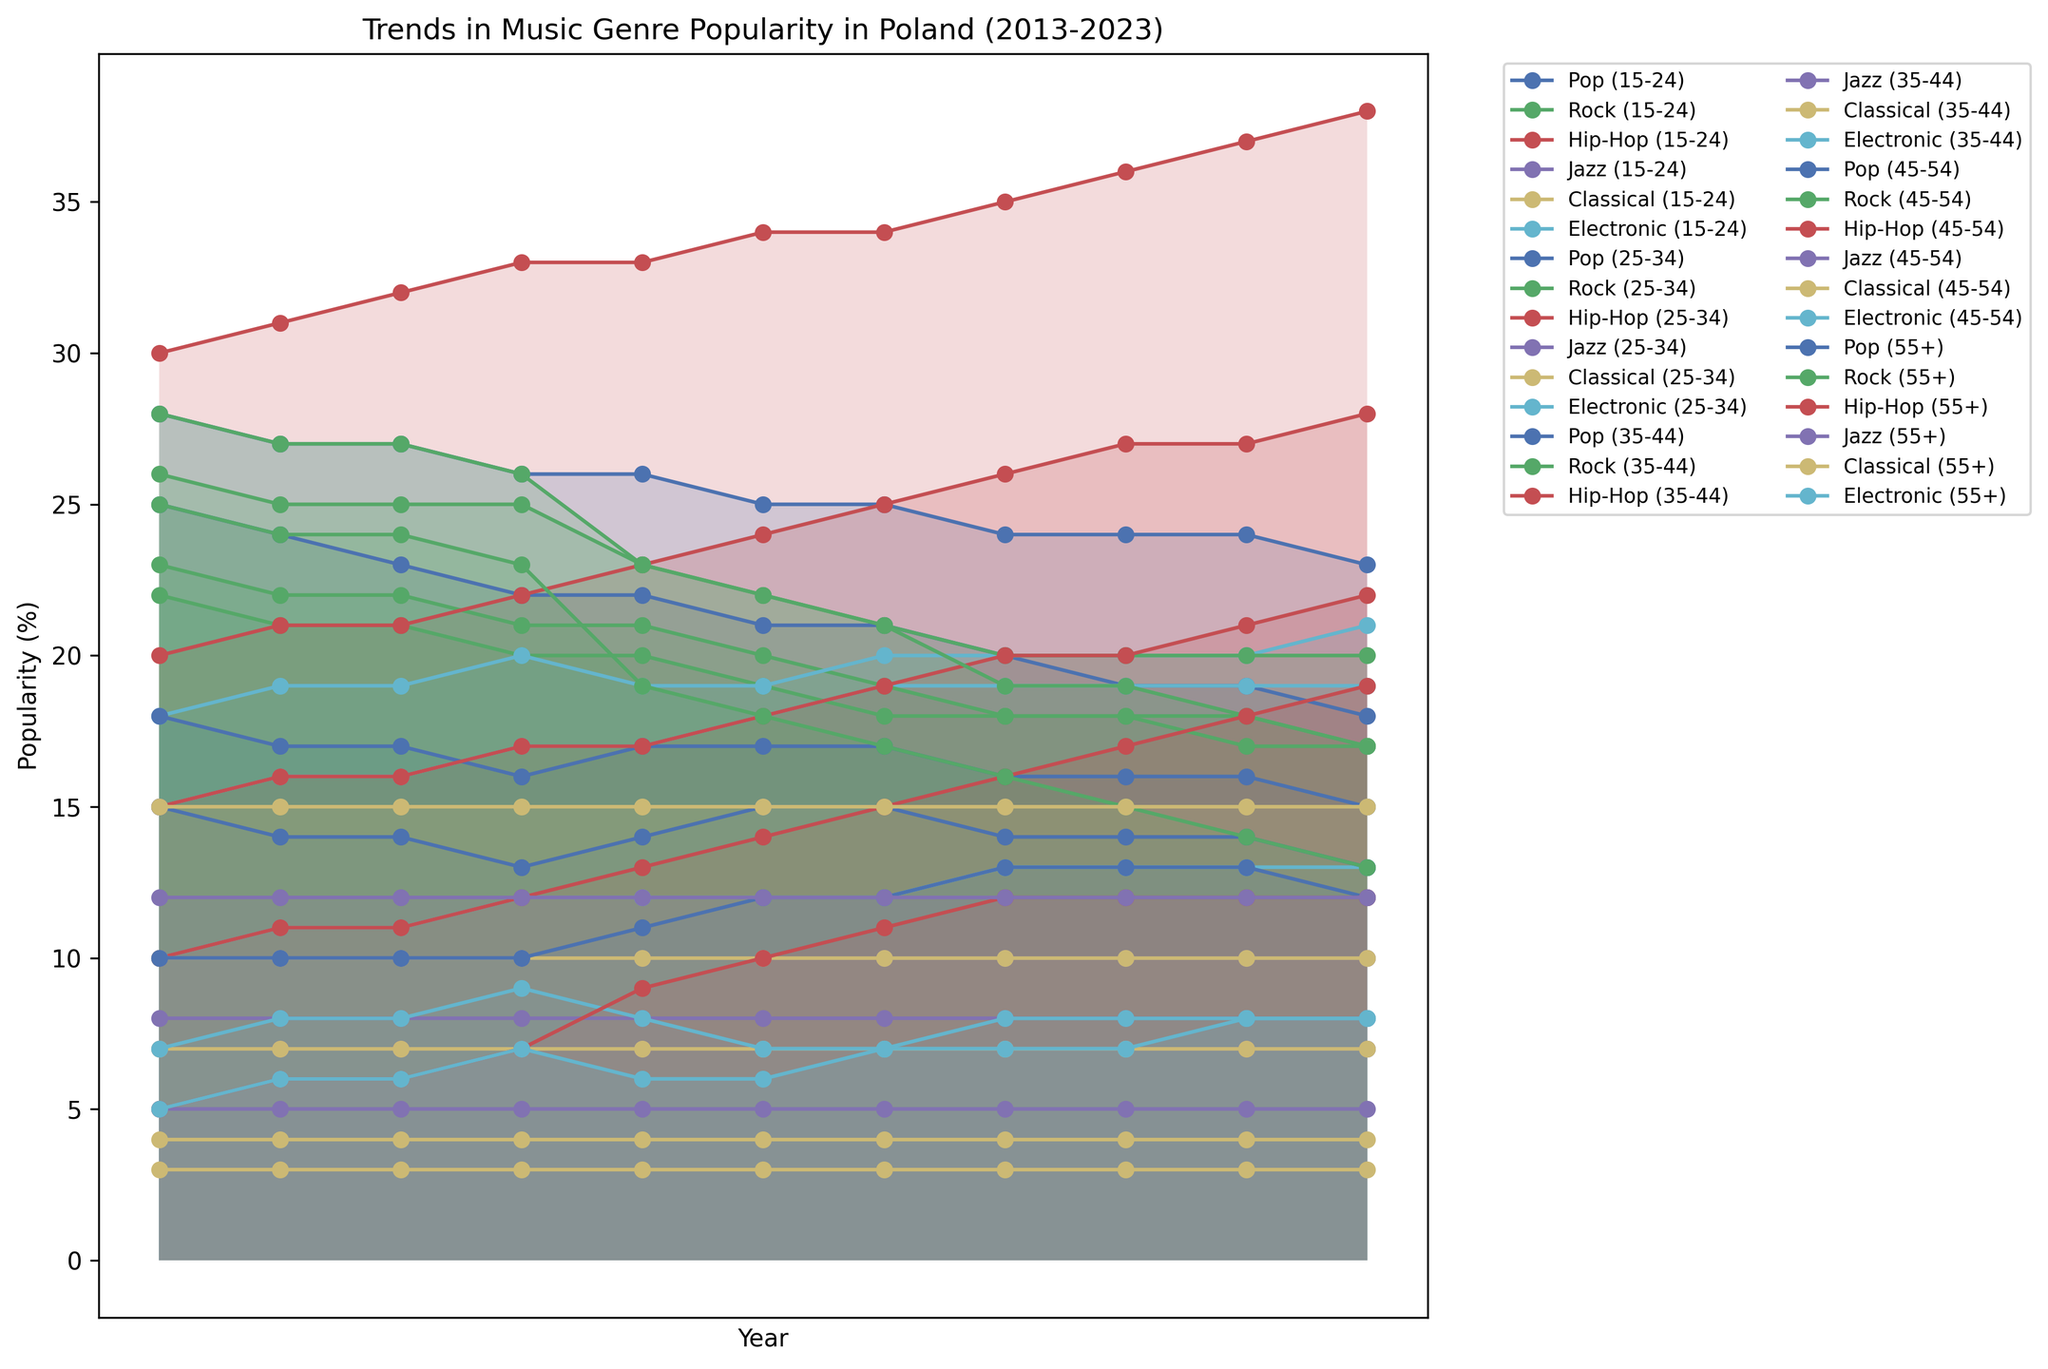Which age group has the highest popularity percentage for Hip-Hop in 2023? To find the highest percentage, look for the data points of Hip-Hop in 2023 among different age groups. The 15-24 age group has the highest value at 38%.
Answer: 15-24 How did the popularity of Electronic music among the 25-34 age group change from 2013 to 2023? Observe the Electronic music trend for the 25-34 age group from 2013 to 2023. It increased from 18% in 2013 to 21% in 2023.
Answer: Increased by 3% Which genre saw the most significant drop in popularity among the 55+ age group from 2013 to 2023? Compare the popularity percentages of different genres for the 55+ age group from 2013 to 2023. Rock declined from 25% to 13%, a drop of 12%.
Answer: Rock Between 2015 and 2020, which age group shows a consistent increase in Hip-Hop popularity? Examine the Hip-Hop trend from 2015 to 2020 for each age group. The 25-34 age group shows a consistent increase from 21% (2015) to 26% (2020).
Answer: 25-34 Which two age groups had similar popularity percentages for Classical music in 2023? Look for the Classical music percentages in 2023. The 45-54 and 55+ age groups both had 15%.
Answer: 45-54 and 55+ In what year did the 15-24 age group start showing a decline in Pop music popularity? Find the year when the decline begins by checking the Pop trend for the 15-24 age group. The decline starts from 2016.
Answer: 2016 What is the trend in Jazz music popularity among the 35-44 age group from 2013 to 2023? Analyze the Jazz trend for the 35-44 age group from 2013 to 2023. It consistently remained stable at 8%.
Answer: Stable How many genres saw an increase in popularity for the 15-24 age group from 2013 to 2023? Compare the popularity of each genre in 2013 and 2023 for the 15-24 age group. Hip-Hop and Electronic increased, so 2 genres saw an increase.
Answer: 2 Which genre became least popular among the 45-54 age group in 2023? Identify the genre with the smallest percentage for the 45-54 age group in 2023. Jazz has the lowest popularity at 10%.
Answer: Jazz Does the 55+ age group show any genre with a steady increase in popularity between 2013 and 2023? Check the trend lines for each genre for the 55+ age group from 2013 to 2023. None of the genres show a steady increase.
Answer: No 